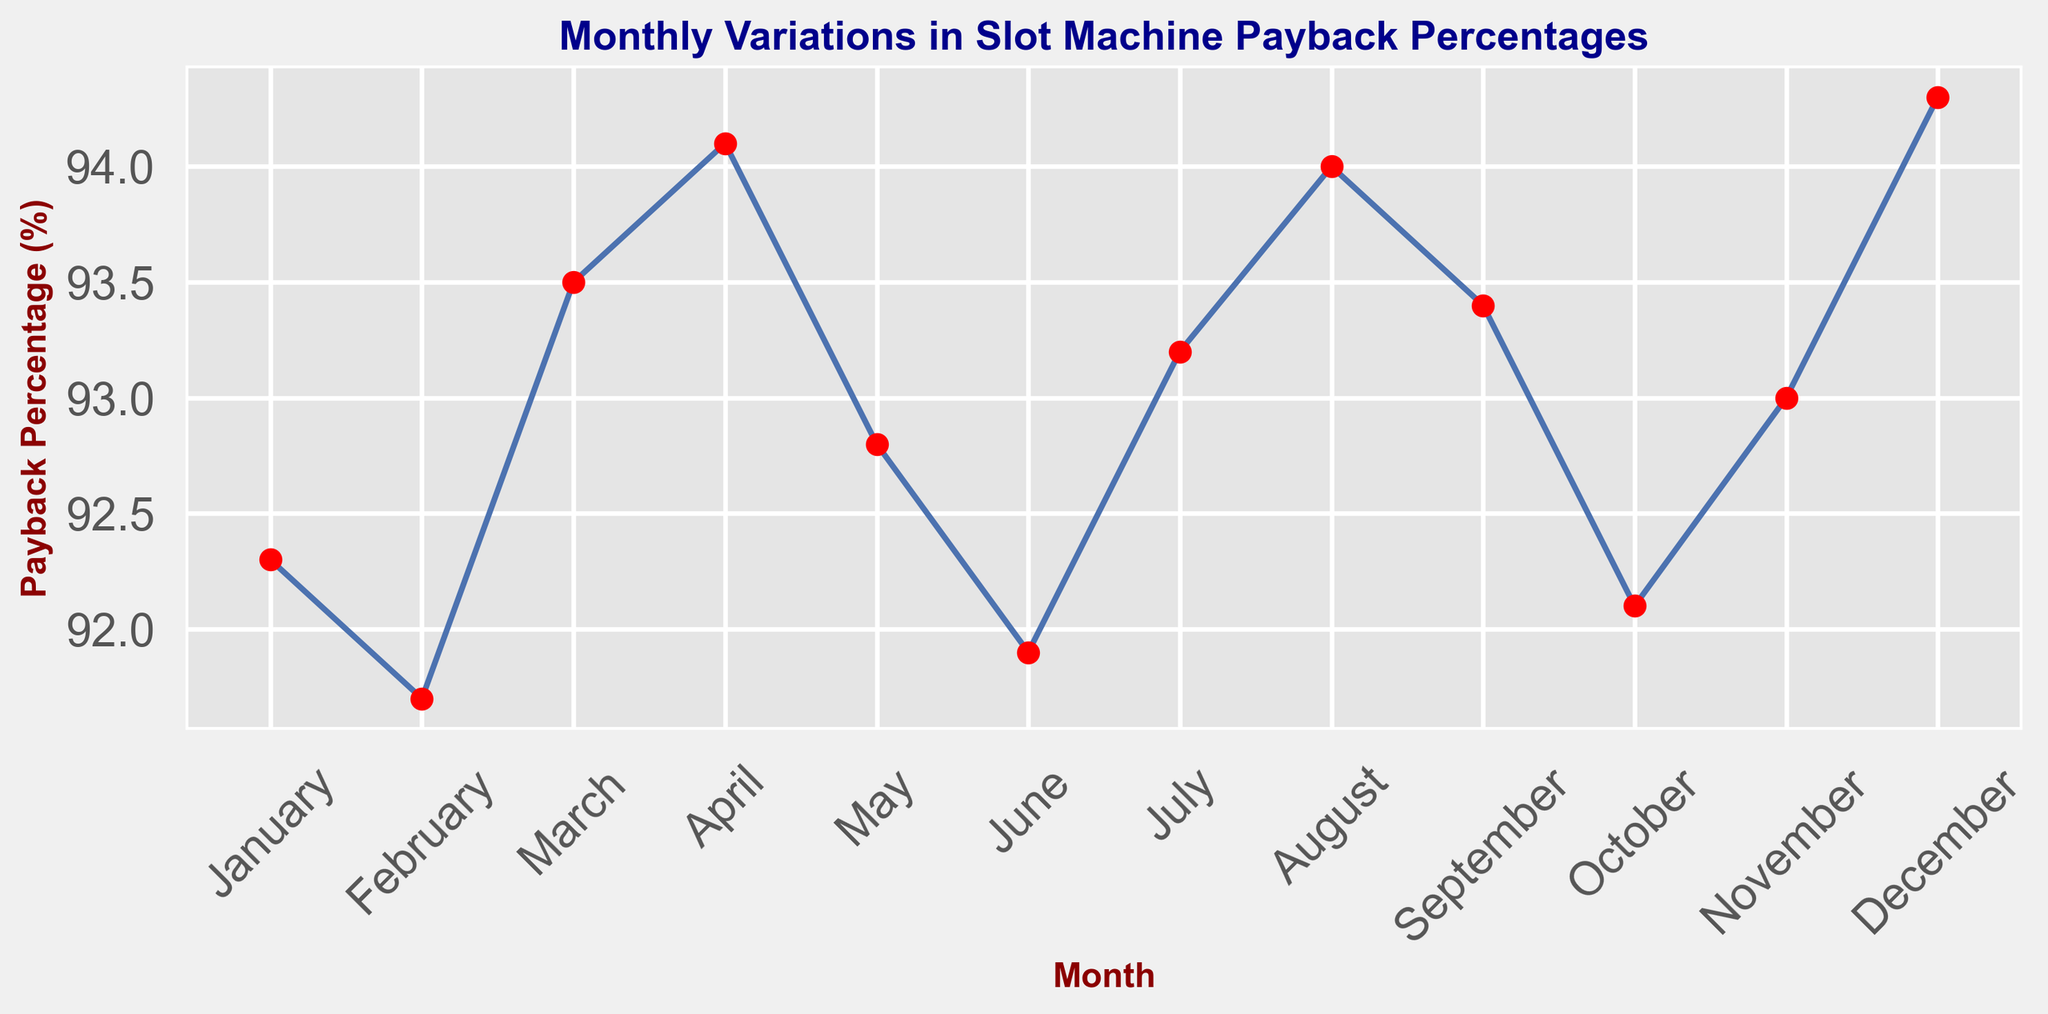What's the highest payback percentage in the year? To find the highest payback percentage, look for the data point that reaches the peak on the vertical axis. In this plot, the highest point occurs in December.
Answer: 94.3% What is the average payback percentage over the year? First, sum all the payback percentages: 92.3 + 91.7 + 93.5 + 94.1 + 92.8 + 91.9 + 93.2 + 94.0 + 93.4 + 92.1 + 93.0 + 94.3 = 1120.3. Then, divide by the number of months: 1120.3 / 12.
Answer: 93.36% During which month did the payback percentage drop the most compared to the previous month? Examine the changes from one month to the next and find the largest decrease. From January to February, the drop is 92.3 - 91.7 = 0.6, etc. The biggest drop is from April to May (94.1 - 92.8 = 1.3).
Answer: May Which months had a payback percentage greater than 94%? Identify months where the payback percentage exceeds 94%. The plot shows two points above 94% in April and December.
Answer: April, December Was the payback percentage higher in the first half or the second half of the year? Calculate the average for January to June: (92.3 + 91.7 + 93.5 + 94.1 + 92.8 + 91.9) / 6 and for July to December: (93.2 + 94.0 + 93.4 + 92.1 + 93.0 + 94.3) / 6. Compare the two averages. First half: 92.88%, Second half: 93.33%.
Answer: Second half What was the difference in payback percentage between the highest and lowest months? Find the highest (94.3% in December) and lowest (91.7% in February), then subtract the lowest from the highest.
Answer: 2.6% Which month saw the largest increase in payback percentage from the previous month? Calculate the differences between consecutive months and identify the largest increase. The largest increase is from February to March (93.5 - 91.7 = 1.8).
Answer: March What is the median payback percentage throughout the year? Order the payback percentages: 91.7, 91.9, 92.1, 92.3, 92.8, 93.0, 93.2, 93.4, 93.5, 94.0, 94.1, 94.3. For an even number of data points, the median is the average of the middle two values (93.0 and 93.2).
Answer: 93.1% How did the payback percentage in October compare to that in June? Locate October (92.1%) and June (91.9%) on the plot and compare their values.
Answer: October was higher Which month had a payback percentage closest to the yearly average? Calculate the yearly average (93.36%) and find the month whose payback percentage is closest to this value. The closest value is July (93.2%).
Answer: July 